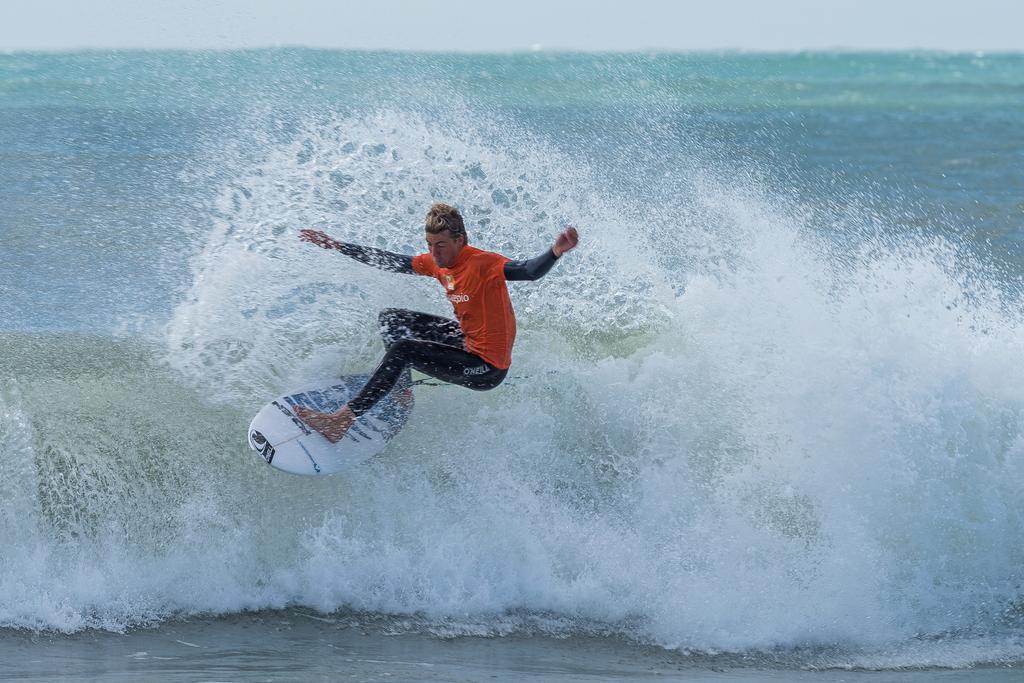What brand are his pants?
Offer a terse response. O'neill. 